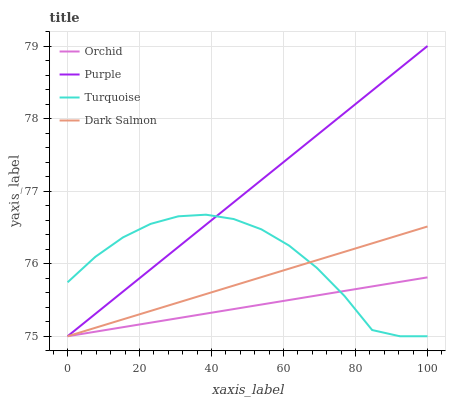Does Orchid have the minimum area under the curve?
Answer yes or no. Yes. Does Purple have the maximum area under the curve?
Answer yes or no. Yes. Does Turquoise have the minimum area under the curve?
Answer yes or no. No. Does Turquoise have the maximum area under the curve?
Answer yes or no. No. Is Orchid the smoothest?
Answer yes or no. Yes. Is Turquoise the roughest?
Answer yes or no. Yes. Is Dark Salmon the smoothest?
Answer yes or no. No. Is Dark Salmon the roughest?
Answer yes or no. No. Does Purple have the lowest value?
Answer yes or no. Yes. Does Purple have the highest value?
Answer yes or no. Yes. Does Turquoise have the highest value?
Answer yes or no. No. Does Turquoise intersect Purple?
Answer yes or no. Yes. Is Turquoise less than Purple?
Answer yes or no. No. Is Turquoise greater than Purple?
Answer yes or no. No. 